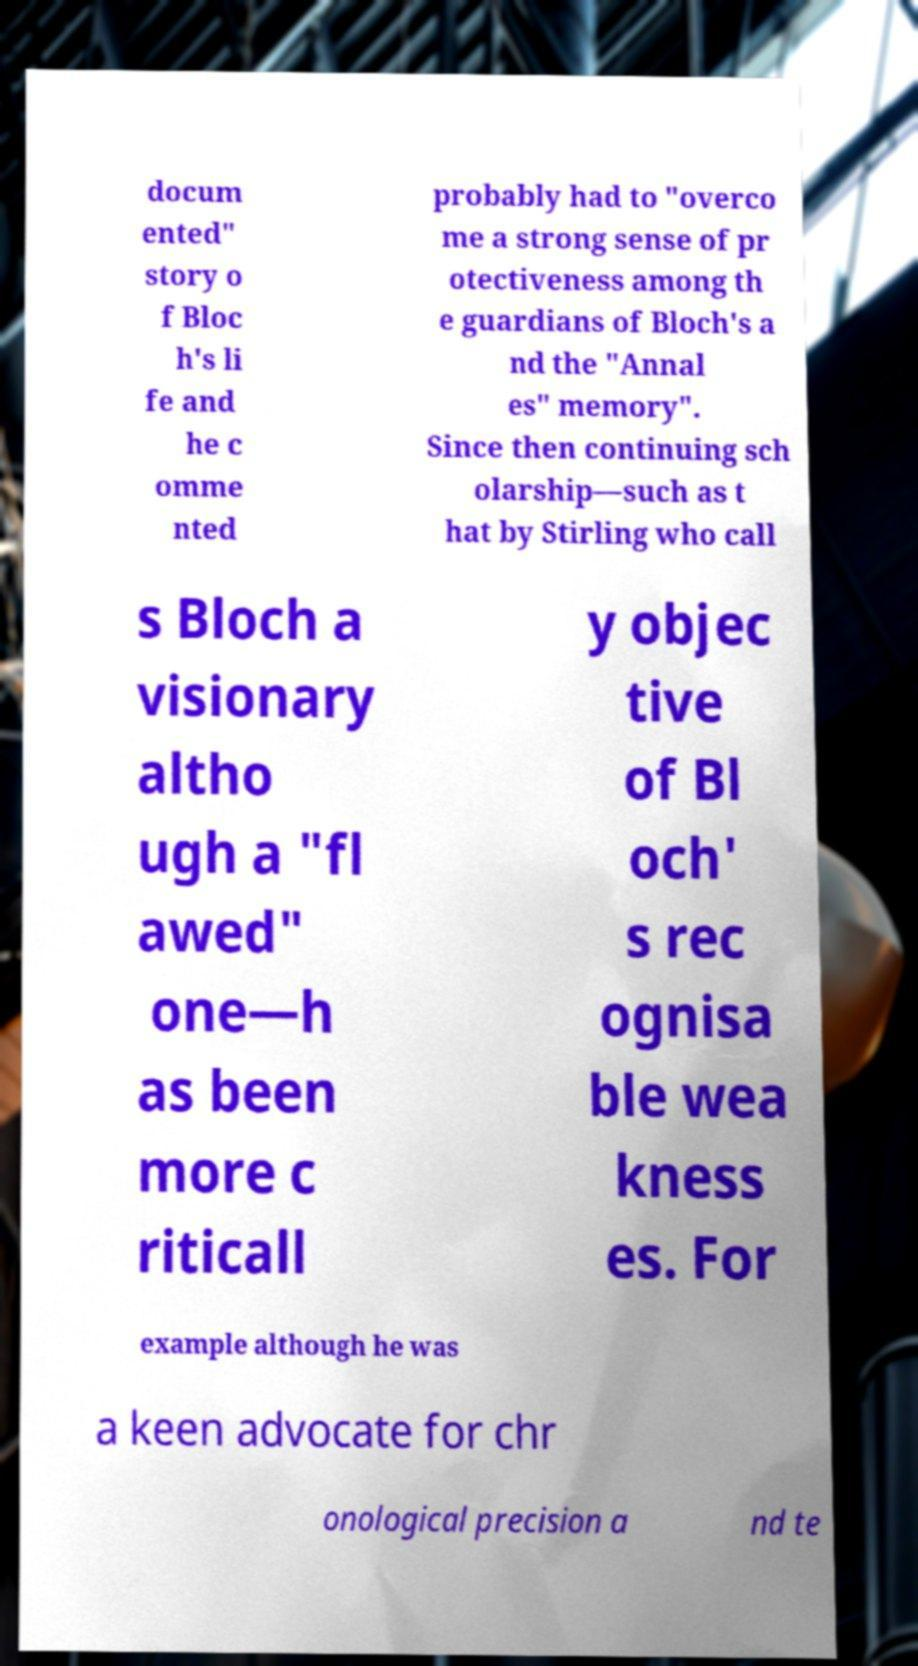I need the written content from this picture converted into text. Can you do that? docum ented" story o f Bloc h's li fe and he c omme nted probably had to "overco me a strong sense of pr otectiveness among th e guardians of Bloch's a nd the "Annal es" memory". Since then continuing sch olarship—such as t hat by Stirling who call s Bloch a visionary altho ugh a "fl awed" one—h as been more c riticall y objec tive of Bl och' s rec ognisa ble wea kness es. For example although he was a keen advocate for chr onological precision a nd te 